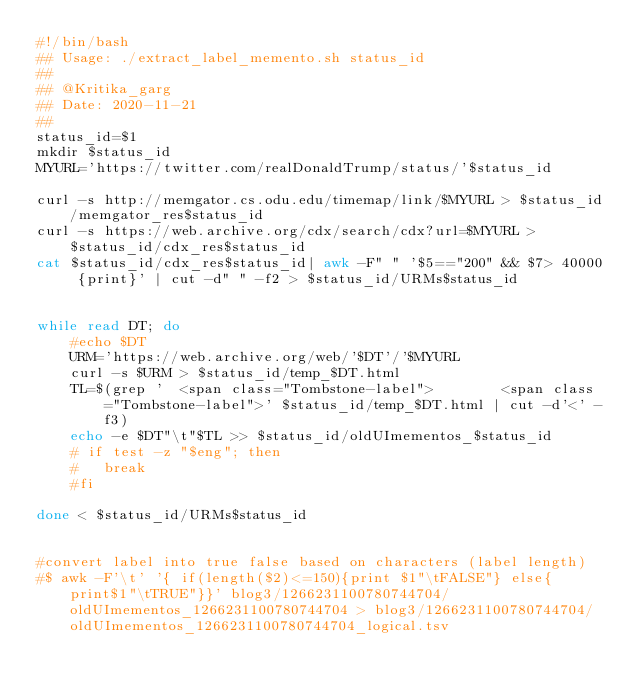<code> <loc_0><loc_0><loc_500><loc_500><_Bash_>#!/bin/bash
## Usage: ./extract_label_memento.sh status_id
##
## @Kritika_garg
## Date: 2020-11-21
##
status_id=$1
mkdir $status_id
MYURL='https://twitter.com/realDonaldTrump/status/'$status_id

curl -s http://memgator.cs.odu.edu/timemap/link/$MYURL > $status_id/memgator_res$status_id 
curl -s https://web.archive.org/cdx/search/cdx?url=$MYURL > $status_id/cdx_res$status_id 
cat $status_id/cdx_res$status_id| awk -F" " '$5=="200" && $7> 40000 {print}' | cut -d" " -f2 > $status_id/URMs$status_id


while read DT; do
	#echo $DT
	URM='https://web.archive.org/web/'$DT'/'$MYURL
	curl -s $URM > $status_id/temp_$DT.html
	TL=$(grep '  <span class="Tombstone-label">        <span class="Tombstone-label">' $status_id/temp_$DT.html | cut -d'<' -f3)
	echo -e $DT"\t"$TL >> $status_id/oldUImementos_$status_id
	# if test -z "$eng"; then
	# 	break
	#fi	

done < $status_id/URMs$status_id


#convert label into true false based on characters (label length)
#$ awk -F'\t' '{ if(length($2)<=150){print $1"\tFALSE"} else{ print$1"\tTRUE"}}' blog3/1266231100780744704/oldUImementos_1266231100780744704 > blog3/1266231100780744704/oldUImementos_1266231100780744704_logical.tsv
</code> 